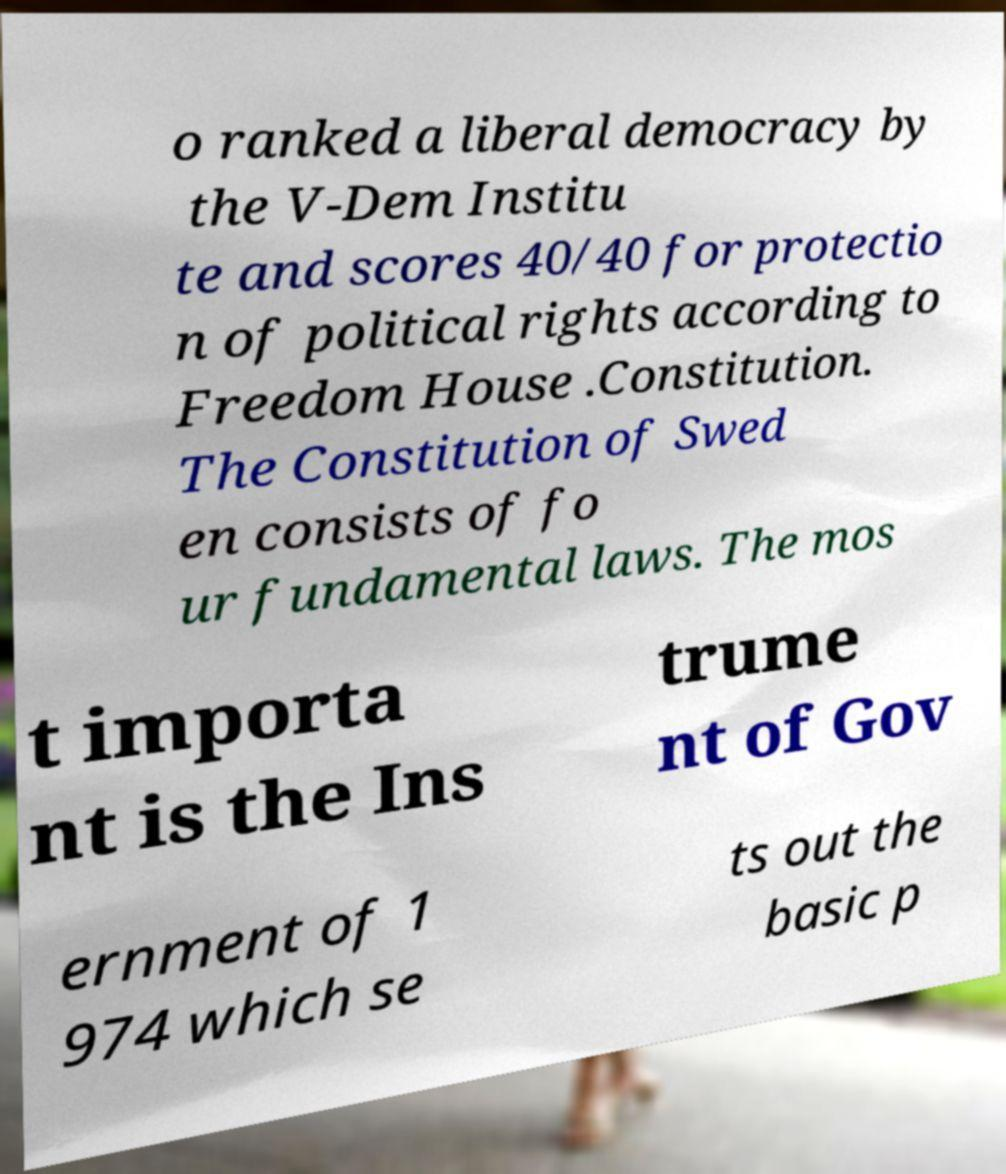Please identify and transcribe the text found in this image. o ranked a liberal democracy by the V-Dem Institu te and scores 40/40 for protectio n of political rights according to Freedom House .Constitution. The Constitution of Swed en consists of fo ur fundamental laws. The mos t importa nt is the Ins trume nt of Gov ernment of 1 974 which se ts out the basic p 